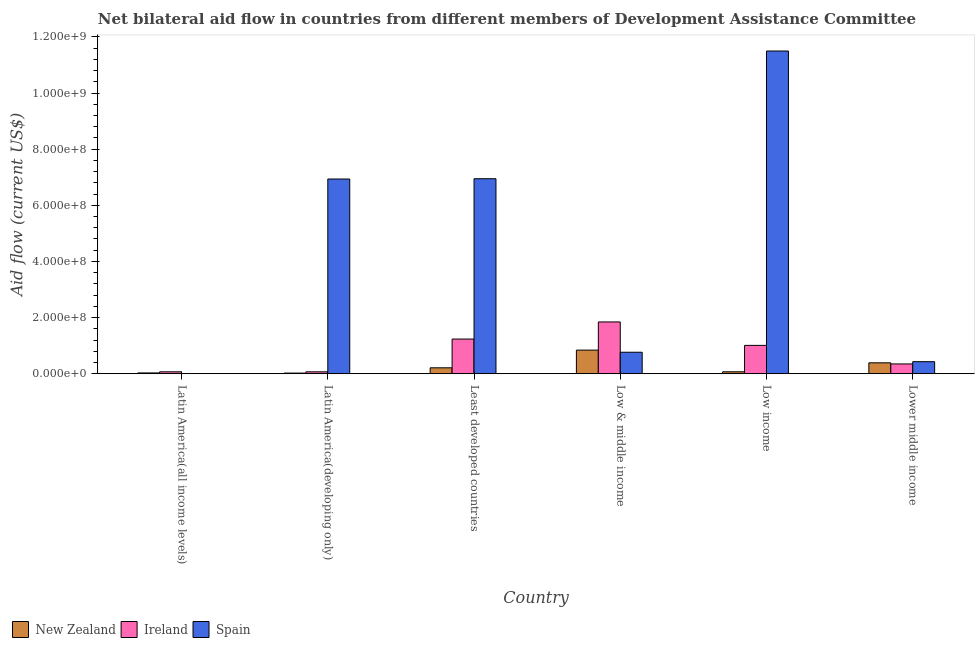How many different coloured bars are there?
Offer a terse response. 3. Are the number of bars on each tick of the X-axis equal?
Your answer should be very brief. No. How many bars are there on the 3rd tick from the right?
Your answer should be very brief. 3. In how many cases, is the number of bars for a given country not equal to the number of legend labels?
Offer a very short reply. 1. What is the amount of aid provided by ireland in Latin America(all income levels)?
Offer a very short reply. 6.87e+06. Across all countries, what is the maximum amount of aid provided by ireland?
Keep it short and to the point. 1.84e+08. Across all countries, what is the minimum amount of aid provided by new zealand?
Provide a short and direct response. 2.35e+06. In which country was the amount of aid provided by ireland maximum?
Offer a very short reply. Low & middle income. What is the total amount of aid provided by ireland in the graph?
Your answer should be compact. 4.58e+08. What is the difference between the amount of aid provided by spain in Least developed countries and that in Low & middle income?
Offer a very short reply. 6.18e+08. What is the difference between the amount of aid provided by new zealand in Latin America(developing only) and the amount of aid provided by ireland in Low & middle income?
Offer a very short reply. -1.82e+08. What is the average amount of aid provided by ireland per country?
Your answer should be compact. 7.63e+07. What is the difference between the amount of aid provided by new zealand and amount of aid provided by spain in Least developed countries?
Ensure brevity in your answer.  -6.74e+08. In how many countries, is the amount of aid provided by new zealand greater than 520000000 US$?
Offer a terse response. 0. What is the ratio of the amount of aid provided by new zealand in Latin America(all income levels) to that in Latin America(developing only)?
Offer a terse response. 1.23. Is the difference between the amount of aid provided by spain in Latin America(developing only) and Least developed countries greater than the difference between the amount of aid provided by new zealand in Latin America(developing only) and Least developed countries?
Offer a terse response. Yes. What is the difference between the highest and the second highest amount of aid provided by ireland?
Provide a short and direct response. 6.09e+07. What is the difference between the highest and the lowest amount of aid provided by spain?
Offer a very short reply. 1.15e+09. Is the sum of the amount of aid provided by new zealand in Latin America(all income levels) and Latin America(developing only) greater than the maximum amount of aid provided by spain across all countries?
Offer a very short reply. No. How many bars are there?
Your answer should be very brief. 17. What is the difference between two consecutive major ticks on the Y-axis?
Provide a short and direct response. 2.00e+08. Are the values on the major ticks of Y-axis written in scientific E-notation?
Your response must be concise. Yes. Does the graph contain any zero values?
Ensure brevity in your answer.  Yes. How are the legend labels stacked?
Your response must be concise. Horizontal. What is the title of the graph?
Offer a terse response. Net bilateral aid flow in countries from different members of Development Assistance Committee. Does "Ages 20-50" appear as one of the legend labels in the graph?
Offer a very short reply. No. What is the Aid flow (current US$) in New Zealand in Latin America(all income levels)?
Your answer should be very brief. 2.90e+06. What is the Aid flow (current US$) in Ireland in Latin America(all income levels)?
Make the answer very short. 6.87e+06. What is the Aid flow (current US$) of Spain in Latin America(all income levels)?
Give a very brief answer. 0. What is the Aid flow (current US$) of New Zealand in Latin America(developing only)?
Your answer should be compact. 2.35e+06. What is the Aid flow (current US$) in Ireland in Latin America(developing only)?
Your response must be concise. 6.83e+06. What is the Aid flow (current US$) in Spain in Latin America(developing only)?
Provide a succinct answer. 6.94e+08. What is the Aid flow (current US$) in New Zealand in Least developed countries?
Offer a very short reply. 2.12e+07. What is the Aid flow (current US$) of Ireland in Least developed countries?
Ensure brevity in your answer.  1.24e+08. What is the Aid flow (current US$) of Spain in Least developed countries?
Offer a very short reply. 6.95e+08. What is the Aid flow (current US$) in New Zealand in Low & middle income?
Offer a very short reply. 8.42e+07. What is the Aid flow (current US$) of Ireland in Low & middle income?
Provide a succinct answer. 1.84e+08. What is the Aid flow (current US$) in Spain in Low & middle income?
Provide a short and direct response. 7.66e+07. What is the Aid flow (current US$) of New Zealand in Low income?
Ensure brevity in your answer.  6.93e+06. What is the Aid flow (current US$) of Ireland in Low income?
Your answer should be very brief. 1.01e+08. What is the Aid flow (current US$) of Spain in Low income?
Your answer should be very brief. 1.15e+09. What is the Aid flow (current US$) of New Zealand in Lower middle income?
Offer a terse response. 3.89e+07. What is the Aid flow (current US$) of Ireland in Lower middle income?
Provide a succinct answer. 3.49e+07. What is the Aid flow (current US$) in Spain in Lower middle income?
Provide a short and direct response. 4.29e+07. Across all countries, what is the maximum Aid flow (current US$) in New Zealand?
Make the answer very short. 8.42e+07. Across all countries, what is the maximum Aid flow (current US$) of Ireland?
Your response must be concise. 1.84e+08. Across all countries, what is the maximum Aid flow (current US$) in Spain?
Offer a terse response. 1.15e+09. Across all countries, what is the minimum Aid flow (current US$) of New Zealand?
Keep it short and to the point. 2.35e+06. Across all countries, what is the minimum Aid flow (current US$) in Ireland?
Give a very brief answer. 6.83e+06. Across all countries, what is the minimum Aid flow (current US$) in Spain?
Your answer should be compact. 0. What is the total Aid flow (current US$) in New Zealand in the graph?
Make the answer very short. 1.56e+08. What is the total Aid flow (current US$) in Ireland in the graph?
Offer a terse response. 4.58e+08. What is the total Aid flow (current US$) of Spain in the graph?
Keep it short and to the point. 2.66e+09. What is the difference between the Aid flow (current US$) of New Zealand in Latin America(all income levels) and that in Latin America(developing only)?
Give a very brief answer. 5.50e+05. What is the difference between the Aid flow (current US$) in New Zealand in Latin America(all income levels) and that in Least developed countries?
Give a very brief answer. -1.83e+07. What is the difference between the Aid flow (current US$) in Ireland in Latin America(all income levels) and that in Least developed countries?
Provide a succinct answer. -1.17e+08. What is the difference between the Aid flow (current US$) in New Zealand in Latin America(all income levels) and that in Low & middle income?
Ensure brevity in your answer.  -8.13e+07. What is the difference between the Aid flow (current US$) of Ireland in Latin America(all income levels) and that in Low & middle income?
Make the answer very short. -1.78e+08. What is the difference between the Aid flow (current US$) of New Zealand in Latin America(all income levels) and that in Low income?
Give a very brief answer. -4.03e+06. What is the difference between the Aid flow (current US$) in Ireland in Latin America(all income levels) and that in Low income?
Your answer should be compact. -9.41e+07. What is the difference between the Aid flow (current US$) in New Zealand in Latin America(all income levels) and that in Lower middle income?
Offer a very short reply. -3.60e+07. What is the difference between the Aid flow (current US$) of Ireland in Latin America(all income levels) and that in Lower middle income?
Offer a very short reply. -2.81e+07. What is the difference between the Aid flow (current US$) of New Zealand in Latin America(developing only) and that in Least developed countries?
Keep it short and to the point. -1.88e+07. What is the difference between the Aid flow (current US$) of Ireland in Latin America(developing only) and that in Least developed countries?
Your response must be concise. -1.17e+08. What is the difference between the Aid flow (current US$) in Spain in Latin America(developing only) and that in Least developed countries?
Provide a short and direct response. -1.04e+06. What is the difference between the Aid flow (current US$) in New Zealand in Latin America(developing only) and that in Low & middle income?
Your answer should be very brief. -8.18e+07. What is the difference between the Aid flow (current US$) in Ireland in Latin America(developing only) and that in Low & middle income?
Make the answer very short. -1.78e+08. What is the difference between the Aid flow (current US$) of Spain in Latin America(developing only) and that in Low & middle income?
Your answer should be very brief. 6.17e+08. What is the difference between the Aid flow (current US$) of New Zealand in Latin America(developing only) and that in Low income?
Your response must be concise. -4.58e+06. What is the difference between the Aid flow (current US$) in Ireland in Latin America(developing only) and that in Low income?
Your response must be concise. -9.42e+07. What is the difference between the Aid flow (current US$) of Spain in Latin America(developing only) and that in Low income?
Keep it short and to the point. -4.56e+08. What is the difference between the Aid flow (current US$) of New Zealand in Latin America(developing only) and that in Lower middle income?
Your response must be concise. -3.65e+07. What is the difference between the Aid flow (current US$) in Ireland in Latin America(developing only) and that in Lower middle income?
Offer a terse response. -2.81e+07. What is the difference between the Aid flow (current US$) of Spain in Latin America(developing only) and that in Lower middle income?
Offer a terse response. 6.51e+08. What is the difference between the Aid flow (current US$) of New Zealand in Least developed countries and that in Low & middle income?
Offer a very short reply. -6.30e+07. What is the difference between the Aid flow (current US$) of Ireland in Least developed countries and that in Low & middle income?
Provide a succinct answer. -6.09e+07. What is the difference between the Aid flow (current US$) of Spain in Least developed countries and that in Low & middle income?
Offer a terse response. 6.18e+08. What is the difference between the Aid flow (current US$) in New Zealand in Least developed countries and that in Low income?
Make the answer very short. 1.42e+07. What is the difference between the Aid flow (current US$) in Ireland in Least developed countries and that in Low income?
Ensure brevity in your answer.  2.26e+07. What is the difference between the Aid flow (current US$) of Spain in Least developed countries and that in Low income?
Your response must be concise. -4.55e+08. What is the difference between the Aid flow (current US$) of New Zealand in Least developed countries and that in Lower middle income?
Give a very brief answer. -1.77e+07. What is the difference between the Aid flow (current US$) in Ireland in Least developed countries and that in Lower middle income?
Keep it short and to the point. 8.86e+07. What is the difference between the Aid flow (current US$) of Spain in Least developed countries and that in Lower middle income?
Give a very brief answer. 6.52e+08. What is the difference between the Aid flow (current US$) of New Zealand in Low & middle income and that in Low income?
Provide a succinct answer. 7.72e+07. What is the difference between the Aid flow (current US$) in Ireland in Low & middle income and that in Low income?
Give a very brief answer. 8.35e+07. What is the difference between the Aid flow (current US$) in Spain in Low & middle income and that in Low income?
Your answer should be very brief. -1.07e+09. What is the difference between the Aid flow (current US$) of New Zealand in Low & middle income and that in Lower middle income?
Offer a terse response. 4.53e+07. What is the difference between the Aid flow (current US$) in Ireland in Low & middle income and that in Lower middle income?
Ensure brevity in your answer.  1.50e+08. What is the difference between the Aid flow (current US$) of Spain in Low & middle income and that in Lower middle income?
Offer a terse response. 3.36e+07. What is the difference between the Aid flow (current US$) of New Zealand in Low income and that in Lower middle income?
Ensure brevity in your answer.  -3.19e+07. What is the difference between the Aid flow (current US$) of Ireland in Low income and that in Lower middle income?
Make the answer very short. 6.61e+07. What is the difference between the Aid flow (current US$) in Spain in Low income and that in Lower middle income?
Provide a succinct answer. 1.11e+09. What is the difference between the Aid flow (current US$) in New Zealand in Latin America(all income levels) and the Aid flow (current US$) in Ireland in Latin America(developing only)?
Offer a very short reply. -3.93e+06. What is the difference between the Aid flow (current US$) in New Zealand in Latin America(all income levels) and the Aid flow (current US$) in Spain in Latin America(developing only)?
Give a very brief answer. -6.91e+08. What is the difference between the Aid flow (current US$) of Ireland in Latin America(all income levels) and the Aid flow (current US$) of Spain in Latin America(developing only)?
Your answer should be compact. -6.87e+08. What is the difference between the Aid flow (current US$) of New Zealand in Latin America(all income levels) and the Aid flow (current US$) of Ireland in Least developed countries?
Offer a terse response. -1.21e+08. What is the difference between the Aid flow (current US$) of New Zealand in Latin America(all income levels) and the Aid flow (current US$) of Spain in Least developed countries?
Keep it short and to the point. -6.92e+08. What is the difference between the Aid flow (current US$) of Ireland in Latin America(all income levels) and the Aid flow (current US$) of Spain in Least developed countries?
Offer a terse response. -6.88e+08. What is the difference between the Aid flow (current US$) in New Zealand in Latin America(all income levels) and the Aid flow (current US$) in Ireland in Low & middle income?
Make the answer very short. -1.82e+08. What is the difference between the Aid flow (current US$) of New Zealand in Latin America(all income levels) and the Aid flow (current US$) of Spain in Low & middle income?
Your response must be concise. -7.37e+07. What is the difference between the Aid flow (current US$) of Ireland in Latin America(all income levels) and the Aid flow (current US$) of Spain in Low & middle income?
Provide a succinct answer. -6.97e+07. What is the difference between the Aid flow (current US$) in New Zealand in Latin America(all income levels) and the Aid flow (current US$) in Ireland in Low income?
Provide a succinct answer. -9.81e+07. What is the difference between the Aid flow (current US$) in New Zealand in Latin America(all income levels) and the Aid flow (current US$) in Spain in Low income?
Give a very brief answer. -1.15e+09. What is the difference between the Aid flow (current US$) of Ireland in Latin America(all income levels) and the Aid flow (current US$) of Spain in Low income?
Make the answer very short. -1.14e+09. What is the difference between the Aid flow (current US$) in New Zealand in Latin America(all income levels) and the Aid flow (current US$) in Ireland in Lower middle income?
Offer a terse response. -3.20e+07. What is the difference between the Aid flow (current US$) of New Zealand in Latin America(all income levels) and the Aid flow (current US$) of Spain in Lower middle income?
Your response must be concise. -4.00e+07. What is the difference between the Aid flow (current US$) of Ireland in Latin America(all income levels) and the Aid flow (current US$) of Spain in Lower middle income?
Provide a short and direct response. -3.61e+07. What is the difference between the Aid flow (current US$) of New Zealand in Latin America(developing only) and the Aid flow (current US$) of Ireland in Least developed countries?
Offer a terse response. -1.21e+08. What is the difference between the Aid flow (current US$) in New Zealand in Latin America(developing only) and the Aid flow (current US$) in Spain in Least developed countries?
Keep it short and to the point. -6.92e+08. What is the difference between the Aid flow (current US$) of Ireland in Latin America(developing only) and the Aid flow (current US$) of Spain in Least developed countries?
Offer a terse response. -6.88e+08. What is the difference between the Aid flow (current US$) of New Zealand in Latin America(developing only) and the Aid flow (current US$) of Ireland in Low & middle income?
Offer a terse response. -1.82e+08. What is the difference between the Aid flow (current US$) of New Zealand in Latin America(developing only) and the Aid flow (current US$) of Spain in Low & middle income?
Keep it short and to the point. -7.42e+07. What is the difference between the Aid flow (current US$) of Ireland in Latin America(developing only) and the Aid flow (current US$) of Spain in Low & middle income?
Give a very brief answer. -6.97e+07. What is the difference between the Aid flow (current US$) in New Zealand in Latin America(developing only) and the Aid flow (current US$) in Ireland in Low income?
Offer a terse response. -9.87e+07. What is the difference between the Aid flow (current US$) of New Zealand in Latin America(developing only) and the Aid flow (current US$) of Spain in Low income?
Provide a succinct answer. -1.15e+09. What is the difference between the Aid flow (current US$) in Ireland in Latin America(developing only) and the Aid flow (current US$) in Spain in Low income?
Your answer should be compact. -1.14e+09. What is the difference between the Aid flow (current US$) in New Zealand in Latin America(developing only) and the Aid flow (current US$) in Ireland in Lower middle income?
Provide a succinct answer. -3.26e+07. What is the difference between the Aid flow (current US$) of New Zealand in Latin America(developing only) and the Aid flow (current US$) of Spain in Lower middle income?
Provide a succinct answer. -4.06e+07. What is the difference between the Aid flow (current US$) in Ireland in Latin America(developing only) and the Aid flow (current US$) in Spain in Lower middle income?
Make the answer very short. -3.61e+07. What is the difference between the Aid flow (current US$) of New Zealand in Least developed countries and the Aid flow (current US$) of Ireland in Low & middle income?
Keep it short and to the point. -1.63e+08. What is the difference between the Aid flow (current US$) of New Zealand in Least developed countries and the Aid flow (current US$) of Spain in Low & middle income?
Ensure brevity in your answer.  -5.54e+07. What is the difference between the Aid flow (current US$) of Ireland in Least developed countries and the Aid flow (current US$) of Spain in Low & middle income?
Offer a terse response. 4.70e+07. What is the difference between the Aid flow (current US$) of New Zealand in Least developed countries and the Aid flow (current US$) of Ireland in Low income?
Your answer should be compact. -7.98e+07. What is the difference between the Aid flow (current US$) in New Zealand in Least developed countries and the Aid flow (current US$) in Spain in Low income?
Provide a short and direct response. -1.13e+09. What is the difference between the Aid flow (current US$) in Ireland in Least developed countries and the Aid flow (current US$) in Spain in Low income?
Provide a succinct answer. -1.03e+09. What is the difference between the Aid flow (current US$) of New Zealand in Least developed countries and the Aid flow (current US$) of Ireland in Lower middle income?
Give a very brief answer. -1.38e+07. What is the difference between the Aid flow (current US$) of New Zealand in Least developed countries and the Aid flow (current US$) of Spain in Lower middle income?
Give a very brief answer. -2.18e+07. What is the difference between the Aid flow (current US$) of Ireland in Least developed countries and the Aid flow (current US$) of Spain in Lower middle income?
Offer a terse response. 8.06e+07. What is the difference between the Aid flow (current US$) of New Zealand in Low & middle income and the Aid flow (current US$) of Ireland in Low income?
Offer a very short reply. -1.68e+07. What is the difference between the Aid flow (current US$) in New Zealand in Low & middle income and the Aid flow (current US$) in Spain in Low income?
Offer a terse response. -1.07e+09. What is the difference between the Aid flow (current US$) in Ireland in Low & middle income and the Aid flow (current US$) in Spain in Low income?
Offer a terse response. -9.65e+08. What is the difference between the Aid flow (current US$) of New Zealand in Low & middle income and the Aid flow (current US$) of Ireland in Lower middle income?
Your answer should be very brief. 4.92e+07. What is the difference between the Aid flow (current US$) in New Zealand in Low & middle income and the Aid flow (current US$) in Spain in Lower middle income?
Your answer should be very brief. 4.12e+07. What is the difference between the Aid flow (current US$) of Ireland in Low & middle income and the Aid flow (current US$) of Spain in Lower middle income?
Your answer should be very brief. 1.42e+08. What is the difference between the Aid flow (current US$) in New Zealand in Low income and the Aid flow (current US$) in Ireland in Lower middle income?
Your answer should be very brief. -2.80e+07. What is the difference between the Aid flow (current US$) of New Zealand in Low income and the Aid flow (current US$) of Spain in Lower middle income?
Offer a very short reply. -3.60e+07. What is the difference between the Aid flow (current US$) of Ireland in Low income and the Aid flow (current US$) of Spain in Lower middle income?
Offer a very short reply. 5.81e+07. What is the average Aid flow (current US$) in New Zealand per country?
Offer a terse response. 2.61e+07. What is the average Aid flow (current US$) in Ireland per country?
Your answer should be compact. 7.63e+07. What is the average Aid flow (current US$) of Spain per country?
Your response must be concise. 4.43e+08. What is the difference between the Aid flow (current US$) of New Zealand and Aid flow (current US$) of Ireland in Latin America(all income levels)?
Your response must be concise. -3.97e+06. What is the difference between the Aid flow (current US$) in New Zealand and Aid flow (current US$) in Ireland in Latin America(developing only)?
Your answer should be very brief. -4.48e+06. What is the difference between the Aid flow (current US$) in New Zealand and Aid flow (current US$) in Spain in Latin America(developing only)?
Give a very brief answer. -6.91e+08. What is the difference between the Aid flow (current US$) of Ireland and Aid flow (current US$) of Spain in Latin America(developing only)?
Your answer should be very brief. -6.87e+08. What is the difference between the Aid flow (current US$) in New Zealand and Aid flow (current US$) in Ireland in Least developed countries?
Your answer should be very brief. -1.02e+08. What is the difference between the Aid flow (current US$) in New Zealand and Aid flow (current US$) in Spain in Least developed countries?
Ensure brevity in your answer.  -6.74e+08. What is the difference between the Aid flow (current US$) of Ireland and Aid flow (current US$) of Spain in Least developed countries?
Make the answer very short. -5.71e+08. What is the difference between the Aid flow (current US$) in New Zealand and Aid flow (current US$) in Ireland in Low & middle income?
Offer a very short reply. -1.00e+08. What is the difference between the Aid flow (current US$) of New Zealand and Aid flow (current US$) of Spain in Low & middle income?
Offer a very short reply. 7.60e+06. What is the difference between the Aid flow (current US$) of Ireland and Aid flow (current US$) of Spain in Low & middle income?
Provide a short and direct response. 1.08e+08. What is the difference between the Aid flow (current US$) in New Zealand and Aid flow (current US$) in Ireland in Low income?
Your answer should be compact. -9.41e+07. What is the difference between the Aid flow (current US$) in New Zealand and Aid flow (current US$) in Spain in Low income?
Provide a short and direct response. -1.14e+09. What is the difference between the Aid flow (current US$) of Ireland and Aid flow (current US$) of Spain in Low income?
Ensure brevity in your answer.  -1.05e+09. What is the difference between the Aid flow (current US$) in New Zealand and Aid flow (current US$) in Ireland in Lower middle income?
Your answer should be very brief. 3.93e+06. What is the difference between the Aid flow (current US$) in New Zealand and Aid flow (current US$) in Spain in Lower middle income?
Make the answer very short. -4.07e+06. What is the difference between the Aid flow (current US$) of Ireland and Aid flow (current US$) of Spain in Lower middle income?
Your answer should be compact. -8.00e+06. What is the ratio of the Aid flow (current US$) in New Zealand in Latin America(all income levels) to that in Latin America(developing only)?
Your answer should be compact. 1.23. What is the ratio of the Aid flow (current US$) of Ireland in Latin America(all income levels) to that in Latin America(developing only)?
Offer a terse response. 1.01. What is the ratio of the Aid flow (current US$) in New Zealand in Latin America(all income levels) to that in Least developed countries?
Ensure brevity in your answer.  0.14. What is the ratio of the Aid flow (current US$) in Ireland in Latin America(all income levels) to that in Least developed countries?
Make the answer very short. 0.06. What is the ratio of the Aid flow (current US$) in New Zealand in Latin America(all income levels) to that in Low & middle income?
Your response must be concise. 0.03. What is the ratio of the Aid flow (current US$) in Ireland in Latin America(all income levels) to that in Low & middle income?
Ensure brevity in your answer.  0.04. What is the ratio of the Aid flow (current US$) of New Zealand in Latin America(all income levels) to that in Low income?
Give a very brief answer. 0.42. What is the ratio of the Aid flow (current US$) of Ireland in Latin America(all income levels) to that in Low income?
Your answer should be compact. 0.07. What is the ratio of the Aid flow (current US$) of New Zealand in Latin America(all income levels) to that in Lower middle income?
Ensure brevity in your answer.  0.07. What is the ratio of the Aid flow (current US$) of Ireland in Latin America(all income levels) to that in Lower middle income?
Offer a terse response. 0.2. What is the ratio of the Aid flow (current US$) in Ireland in Latin America(developing only) to that in Least developed countries?
Ensure brevity in your answer.  0.06. What is the ratio of the Aid flow (current US$) in New Zealand in Latin America(developing only) to that in Low & middle income?
Provide a succinct answer. 0.03. What is the ratio of the Aid flow (current US$) of Ireland in Latin America(developing only) to that in Low & middle income?
Give a very brief answer. 0.04. What is the ratio of the Aid flow (current US$) in Spain in Latin America(developing only) to that in Low & middle income?
Offer a very short reply. 9.06. What is the ratio of the Aid flow (current US$) in New Zealand in Latin America(developing only) to that in Low income?
Your response must be concise. 0.34. What is the ratio of the Aid flow (current US$) of Ireland in Latin America(developing only) to that in Low income?
Keep it short and to the point. 0.07. What is the ratio of the Aid flow (current US$) in Spain in Latin America(developing only) to that in Low income?
Ensure brevity in your answer.  0.6. What is the ratio of the Aid flow (current US$) of New Zealand in Latin America(developing only) to that in Lower middle income?
Your response must be concise. 0.06. What is the ratio of the Aid flow (current US$) in Ireland in Latin America(developing only) to that in Lower middle income?
Provide a short and direct response. 0.2. What is the ratio of the Aid flow (current US$) of Spain in Latin America(developing only) to that in Lower middle income?
Make the answer very short. 16.15. What is the ratio of the Aid flow (current US$) of New Zealand in Least developed countries to that in Low & middle income?
Your answer should be very brief. 0.25. What is the ratio of the Aid flow (current US$) of Ireland in Least developed countries to that in Low & middle income?
Offer a terse response. 0.67. What is the ratio of the Aid flow (current US$) of Spain in Least developed countries to that in Low & middle income?
Give a very brief answer. 9.07. What is the ratio of the Aid flow (current US$) in New Zealand in Least developed countries to that in Low income?
Your answer should be compact. 3.05. What is the ratio of the Aid flow (current US$) in Ireland in Least developed countries to that in Low income?
Your answer should be very brief. 1.22. What is the ratio of the Aid flow (current US$) of Spain in Least developed countries to that in Low income?
Your response must be concise. 0.6. What is the ratio of the Aid flow (current US$) of New Zealand in Least developed countries to that in Lower middle income?
Make the answer very short. 0.54. What is the ratio of the Aid flow (current US$) in Ireland in Least developed countries to that in Lower middle income?
Your answer should be compact. 3.54. What is the ratio of the Aid flow (current US$) in Spain in Least developed countries to that in Lower middle income?
Ensure brevity in your answer.  16.18. What is the ratio of the Aid flow (current US$) of New Zealand in Low & middle income to that in Low income?
Your answer should be very brief. 12.15. What is the ratio of the Aid flow (current US$) of Ireland in Low & middle income to that in Low income?
Ensure brevity in your answer.  1.83. What is the ratio of the Aid flow (current US$) in Spain in Low & middle income to that in Low income?
Offer a terse response. 0.07. What is the ratio of the Aid flow (current US$) in New Zealand in Low & middle income to that in Lower middle income?
Make the answer very short. 2.17. What is the ratio of the Aid flow (current US$) of Ireland in Low & middle income to that in Lower middle income?
Provide a short and direct response. 5.28. What is the ratio of the Aid flow (current US$) in Spain in Low & middle income to that in Lower middle income?
Keep it short and to the point. 1.78. What is the ratio of the Aid flow (current US$) of New Zealand in Low income to that in Lower middle income?
Offer a very short reply. 0.18. What is the ratio of the Aid flow (current US$) in Ireland in Low income to that in Lower middle income?
Make the answer very short. 2.89. What is the ratio of the Aid flow (current US$) of Spain in Low income to that in Lower middle income?
Your answer should be compact. 26.77. What is the difference between the highest and the second highest Aid flow (current US$) in New Zealand?
Your response must be concise. 4.53e+07. What is the difference between the highest and the second highest Aid flow (current US$) in Ireland?
Your response must be concise. 6.09e+07. What is the difference between the highest and the second highest Aid flow (current US$) of Spain?
Your response must be concise. 4.55e+08. What is the difference between the highest and the lowest Aid flow (current US$) of New Zealand?
Offer a very short reply. 8.18e+07. What is the difference between the highest and the lowest Aid flow (current US$) of Ireland?
Offer a terse response. 1.78e+08. What is the difference between the highest and the lowest Aid flow (current US$) of Spain?
Ensure brevity in your answer.  1.15e+09. 